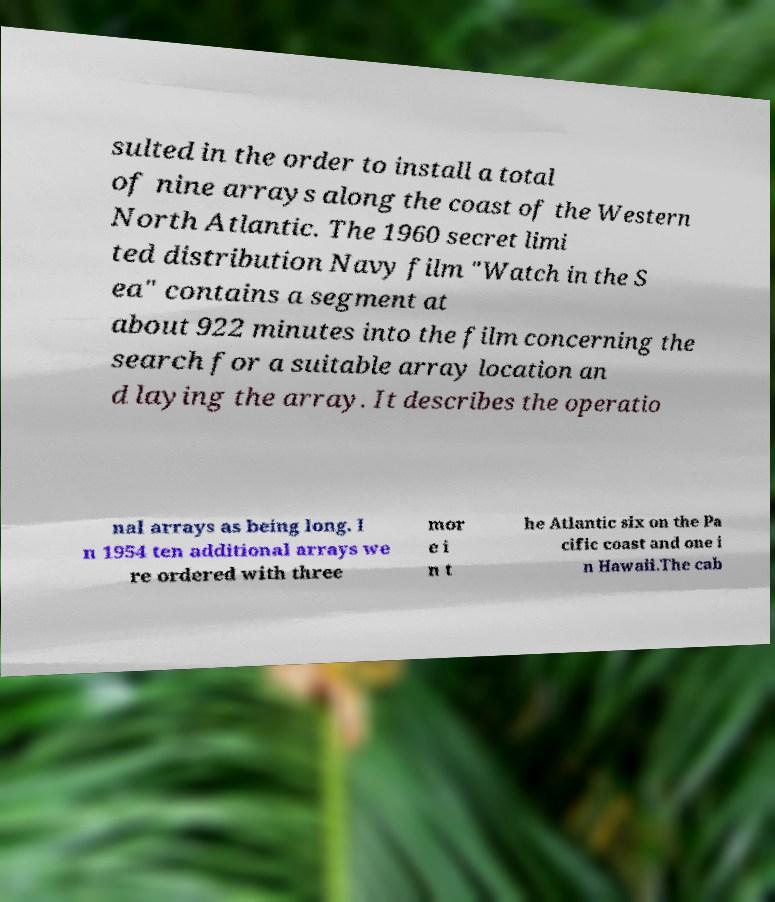I need the written content from this picture converted into text. Can you do that? sulted in the order to install a total of nine arrays along the coast of the Western North Atlantic. The 1960 secret limi ted distribution Navy film "Watch in the S ea" contains a segment at about 922 minutes into the film concerning the search for a suitable array location an d laying the array. It describes the operatio nal arrays as being long. I n 1954 ten additional arrays we re ordered with three mor e i n t he Atlantic six on the Pa cific coast and one i n Hawaii.The cab 